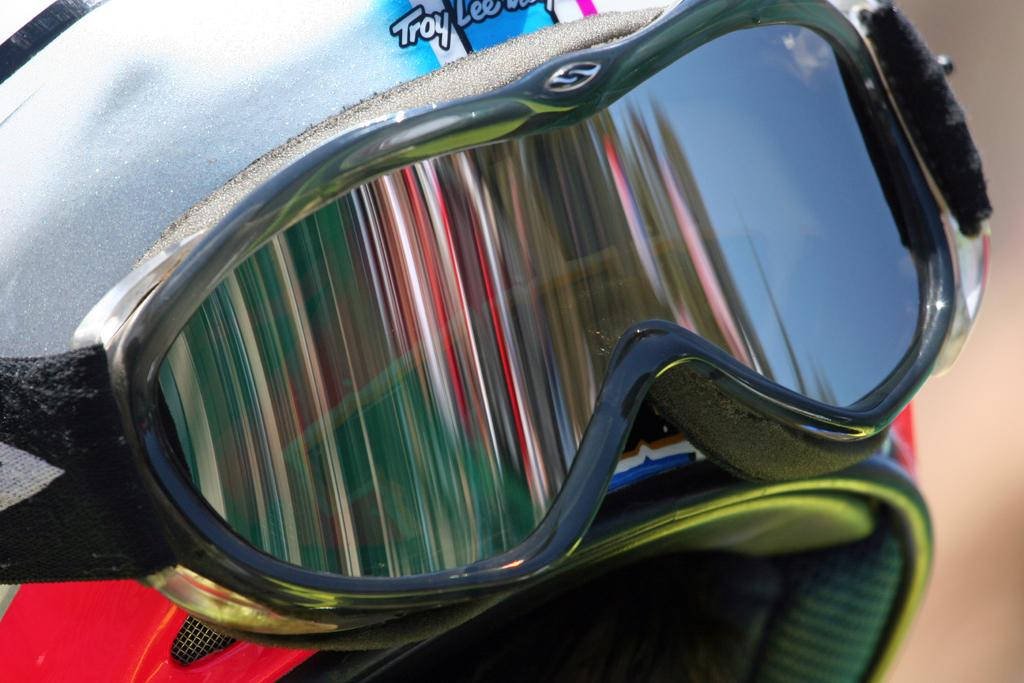What type of protective gear is present in the image? There is a helmet in the image. What additional feature is present on the helmet? The helmet has goggles on it. Can you describe the background of the image? The background of the image is blurry. What type of bean is visible in the image? There is no bean present in the image. Is there a stranger interacting with the helmet in the image? There is no stranger present in the image. 